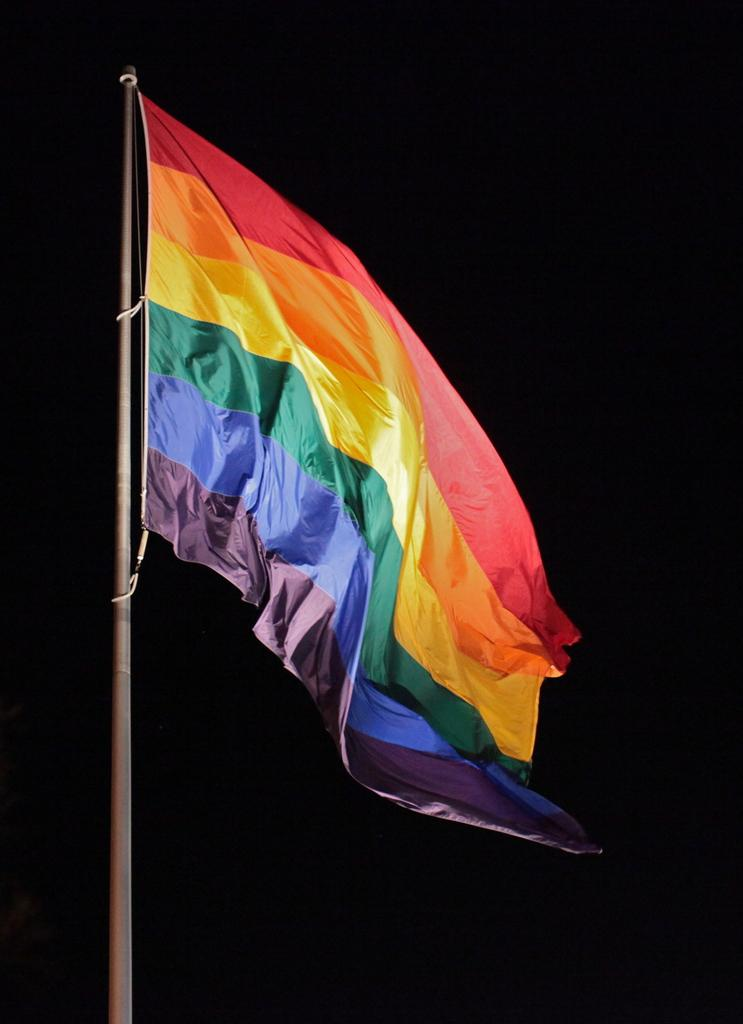What is the main object in the image? There is a flag in the image. What type of circle can be seen on the flag in the image? There is no circle present on the flag in the image. 